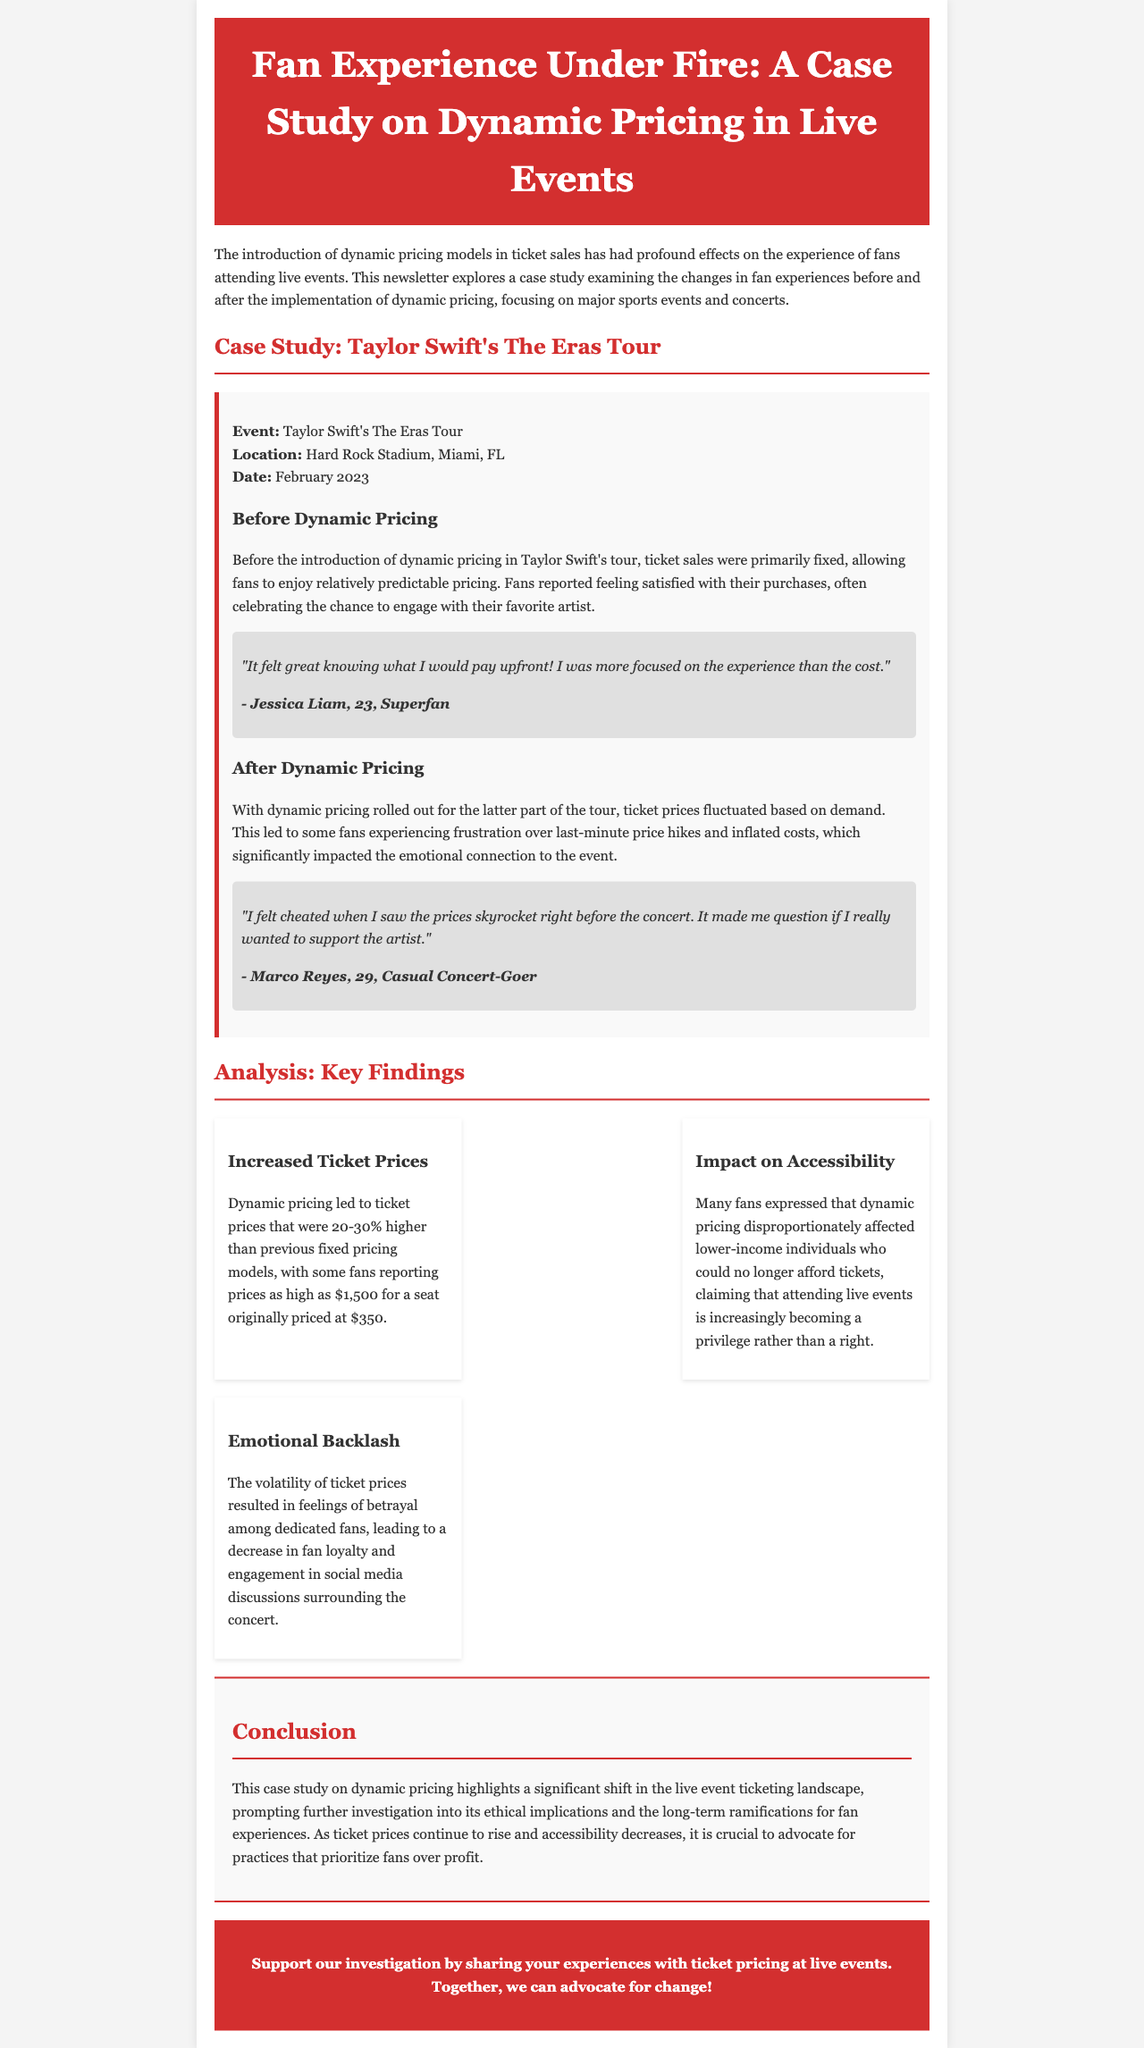What was the event discussed in the case study? The event discussed in the case study is Taylor Swift's The Eras Tour.
Answer: Taylor Swift's The Eras Tour When did the event take place? The date of the event is mentioned as February 2023.
Answer: February 2023 What percentage increase in ticket prices was reported after dynamic pricing? The document states that dynamic pricing led to ticket prices that were 20-30% higher than previous fixed pricing models.
Answer: 20-30% Who expressed feeling cheated by the price increases? The person's name mentioned who felt cheated is Marco Reyes.
Answer: Marco Reyes What emotional impact did dynamic pricing have on fans? The document notes that dynamic pricing resulted in feelings of betrayal among dedicated fans.
Answer: Betrayal What is the focus of the newsletter? The newsletter focuses on the effects of dynamic pricing models on fan experiences at live events.
Answer: Effects of dynamic pricing on fan experiences What was one major finding regarding accessibility? One finding mentioned is that dynamic pricing disproportionately affected lower-income individuals.
Answer: Disproportionately affected lower-income individuals What kind of invitation does the newsletter end with? The invitation at the end encourages sharing experiences with ticket pricing.
Answer: Sharing experiences with ticket pricing 